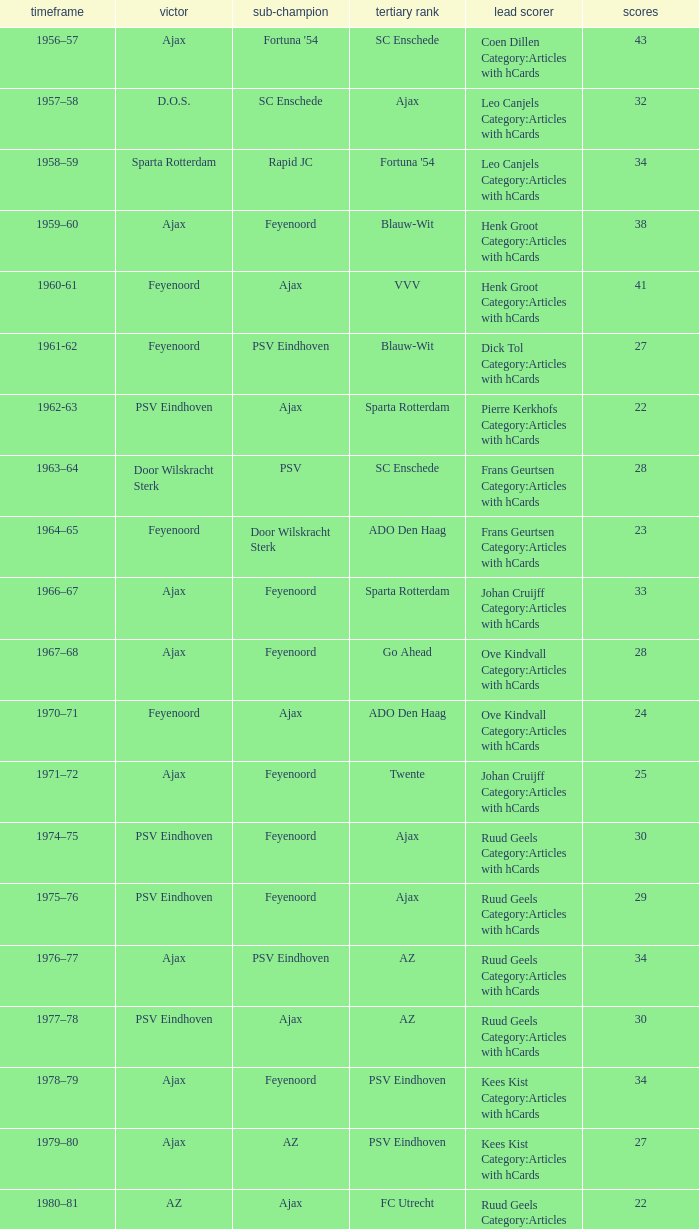When twente came in third place and ajax was the winner what are the seasons? 1971–72, 1989-90. 